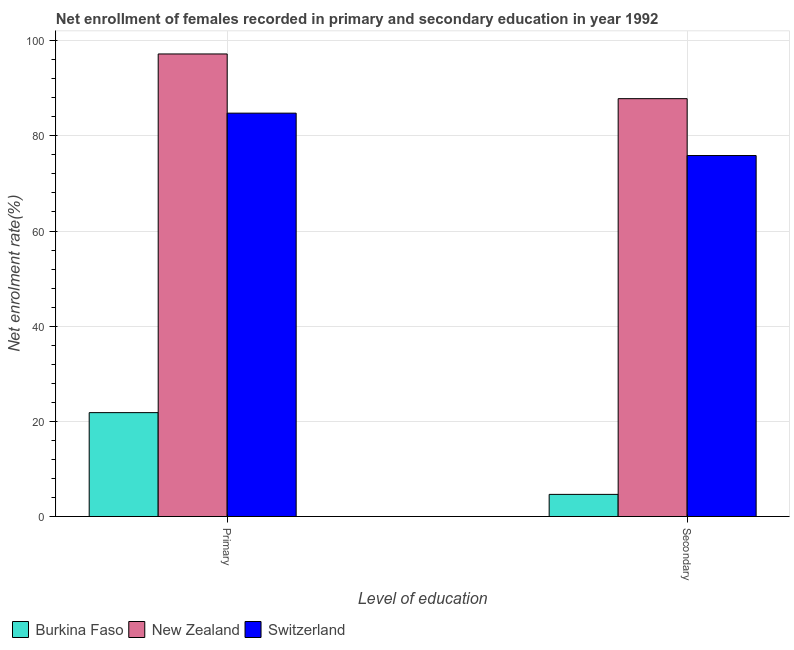How many different coloured bars are there?
Make the answer very short. 3. Are the number of bars on each tick of the X-axis equal?
Keep it short and to the point. Yes. How many bars are there on the 1st tick from the left?
Provide a short and direct response. 3. How many bars are there on the 2nd tick from the right?
Keep it short and to the point. 3. What is the label of the 1st group of bars from the left?
Your answer should be very brief. Primary. What is the enrollment rate in secondary education in Switzerland?
Offer a very short reply. 75.86. Across all countries, what is the maximum enrollment rate in secondary education?
Your response must be concise. 87.82. Across all countries, what is the minimum enrollment rate in secondary education?
Offer a terse response. 4.65. In which country was the enrollment rate in primary education maximum?
Offer a terse response. New Zealand. In which country was the enrollment rate in primary education minimum?
Provide a short and direct response. Burkina Faso. What is the total enrollment rate in primary education in the graph?
Give a very brief answer. 203.82. What is the difference between the enrollment rate in primary education in New Zealand and that in Burkina Faso?
Your response must be concise. 75.38. What is the difference between the enrollment rate in primary education in Burkina Faso and the enrollment rate in secondary education in Switzerland?
Ensure brevity in your answer.  -54.03. What is the average enrollment rate in primary education per country?
Offer a terse response. 67.94. What is the difference between the enrollment rate in secondary education and enrollment rate in primary education in Switzerland?
Provide a short and direct response. -8.91. What is the ratio of the enrollment rate in primary education in New Zealand to that in Switzerland?
Ensure brevity in your answer.  1.15. Is the enrollment rate in primary education in Burkina Faso less than that in Switzerland?
Your answer should be compact. Yes. What does the 3rd bar from the left in Primary represents?
Offer a terse response. Switzerland. What does the 1st bar from the right in Secondary represents?
Provide a short and direct response. Switzerland. How many bars are there?
Keep it short and to the point. 6. Are all the bars in the graph horizontal?
Offer a very short reply. No. What is the difference between two consecutive major ticks on the Y-axis?
Offer a terse response. 20. Are the values on the major ticks of Y-axis written in scientific E-notation?
Provide a succinct answer. No. Does the graph contain any zero values?
Offer a very short reply. No. How are the legend labels stacked?
Keep it short and to the point. Horizontal. What is the title of the graph?
Ensure brevity in your answer.  Net enrollment of females recorded in primary and secondary education in year 1992. Does "Bosnia and Herzegovina" appear as one of the legend labels in the graph?
Provide a succinct answer. No. What is the label or title of the X-axis?
Ensure brevity in your answer.  Level of education. What is the label or title of the Y-axis?
Make the answer very short. Net enrolment rate(%). What is the Net enrolment rate(%) in Burkina Faso in Primary?
Offer a very short reply. 21.83. What is the Net enrolment rate(%) in New Zealand in Primary?
Provide a succinct answer. 97.21. What is the Net enrolment rate(%) of Switzerland in Primary?
Your answer should be very brief. 84.77. What is the Net enrolment rate(%) in Burkina Faso in Secondary?
Keep it short and to the point. 4.65. What is the Net enrolment rate(%) of New Zealand in Secondary?
Ensure brevity in your answer.  87.82. What is the Net enrolment rate(%) of Switzerland in Secondary?
Keep it short and to the point. 75.86. Across all Level of education, what is the maximum Net enrolment rate(%) of Burkina Faso?
Offer a terse response. 21.83. Across all Level of education, what is the maximum Net enrolment rate(%) in New Zealand?
Offer a very short reply. 97.21. Across all Level of education, what is the maximum Net enrolment rate(%) in Switzerland?
Your response must be concise. 84.77. Across all Level of education, what is the minimum Net enrolment rate(%) of Burkina Faso?
Give a very brief answer. 4.65. Across all Level of education, what is the minimum Net enrolment rate(%) of New Zealand?
Provide a short and direct response. 87.82. Across all Level of education, what is the minimum Net enrolment rate(%) of Switzerland?
Offer a very short reply. 75.86. What is the total Net enrolment rate(%) of Burkina Faso in the graph?
Keep it short and to the point. 26.49. What is the total Net enrolment rate(%) of New Zealand in the graph?
Your answer should be very brief. 185.03. What is the total Net enrolment rate(%) of Switzerland in the graph?
Keep it short and to the point. 160.63. What is the difference between the Net enrolment rate(%) in Burkina Faso in Primary and that in Secondary?
Offer a terse response. 17.18. What is the difference between the Net enrolment rate(%) of New Zealand in Primary and that in Secondary?
Provide a succinct answer. 9.4. What is the difference between the Net enrolment rate(%) of Switzerland in Primary and that in Secondary?
Your answer should be compact. 8.91. What is the difference between the Net enrolment rate(%) in Burkina Faso in Primary and the Net enrolment rate(%) in New Zealand in Secondary?
Offer a terse response. -65.98. What is the difference between the Net enrolment rate(%) in Burkina Faso in Primary and the Net enrolment rate(%) in Switzerland in Secondary?
Offer a very short reply. -54.03. What is the difference between the Net enrolment rate(%) of New Zealand in Primary and the Net enrolment rate(%) of Switzerland in Secondary?
Keep it short and to the point. 21.35. What is the average Net enrolment rate(%) in Burkina Faso per Level of education?
Your answer should be compact. 13.24. What is the average Net enrolment rate(%) in New Zealand per Level of education?
Ensure brevity in your answer.  92.51. What is the average Net enrolment rate(%) in Switzerland per Level of education?
Your answer should be compact. 80.32. What is the difference between the Net enrolment rate(%) of Burkina Faso and Net enrolment rate(%) of New Zealand in Primary?
Ensure brevity in your answer.  -75.38. What is the difference between the Net enrolment rate(%) in Burkina Faso and Net enrolment rate(%) in Switzerland in Primary?
Your answer should be very brief. -62.94. What is the difference between the Net enrolment rate(%) of New Zealand and Net enrolment rate(%) of Switzerland in Primary?
Offer a very short reply. 12.44. What is the difference between the Net enrolment rate(%) in Burkina Faso and Net enrolment rate(%) in New Zealand in Secondary?
Your answer should be very brief. -83.16. What is the difference between the Net enrolment rate(%) of Burkina Faso and Net enrolment rate(%) of Switzerland in Secondary?
Provide a succinct answer. -71.21. What is the difference between the Net enrolment rate(%) in New Zealand and Net enrolment rate(%) in Switzerland in Secondary?
Your response must be concise. 11.95. What is the ratio of the Net enrolment rate(%) in Burkina Faso in Primary to that in Secondary?
Ensure brevity in your answer.  4.69. What is the ratio of the Net enrolment rate(%) in New Zealand in Primary to that in Secondary?
Your answer should be compact. 1.11. What is the ratio of the Net enrolment rate(%) of Switzerland in Primary to that in Secondary?
Make the answer very short. 1.12. What is the difference between the highest and the second highest Net enrolment rate(%) in Burkina Faso?
Provide a short and direct response. 17.18. What is the difference between the highest and the second highest Net enrolment rate(%) in New Zealand?
Ensure brevity in your answer.  9.4. What is the difference between the highest and the second highest Net enrolment rate(%) in Switzerland?
Provide a short and direct response. 8.91. What is the difference between the highest and the lowest Net enrolment rate(%) in Burkina Faso?
Make the answer very short. 17.18. What is the difference between the highest and the lowest Net enrolment rate(%) of New Zealand?
Your answer should be compact. 9.4. What is the difference between the highest and the lowest Net enrolment rate(%) of Switzerland?
Keep it short and to the point. 8.91. 